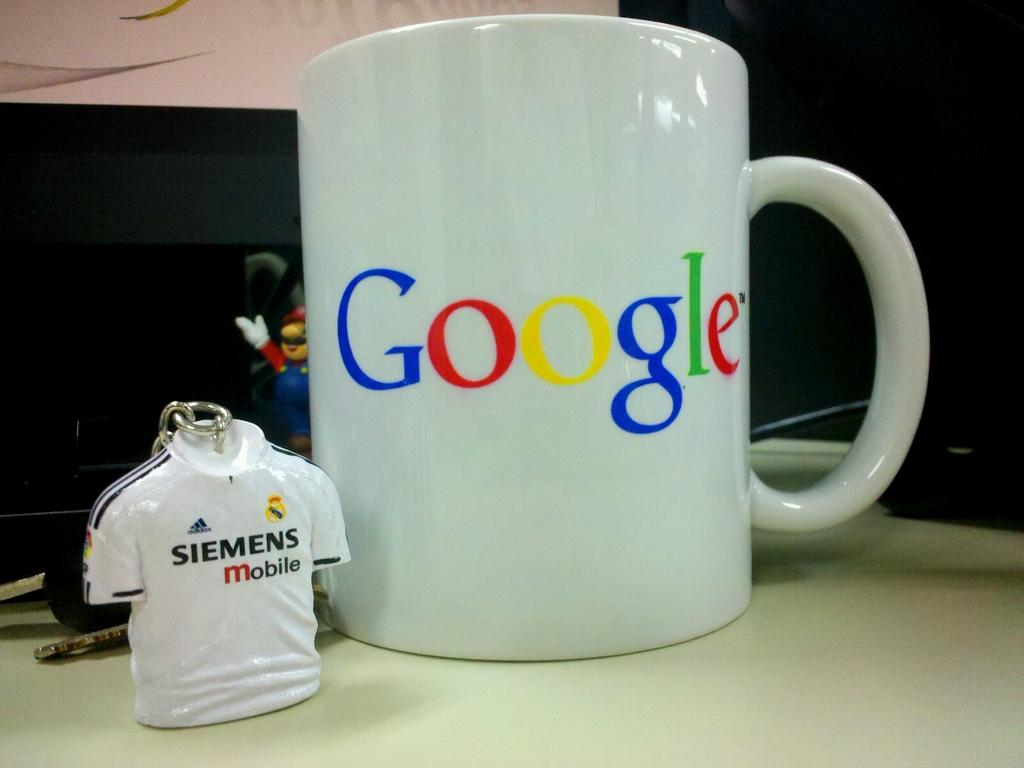Provide a one-sentence caption for the provided image. Google mug sitting on the counter with Mario and a sports shirt. 